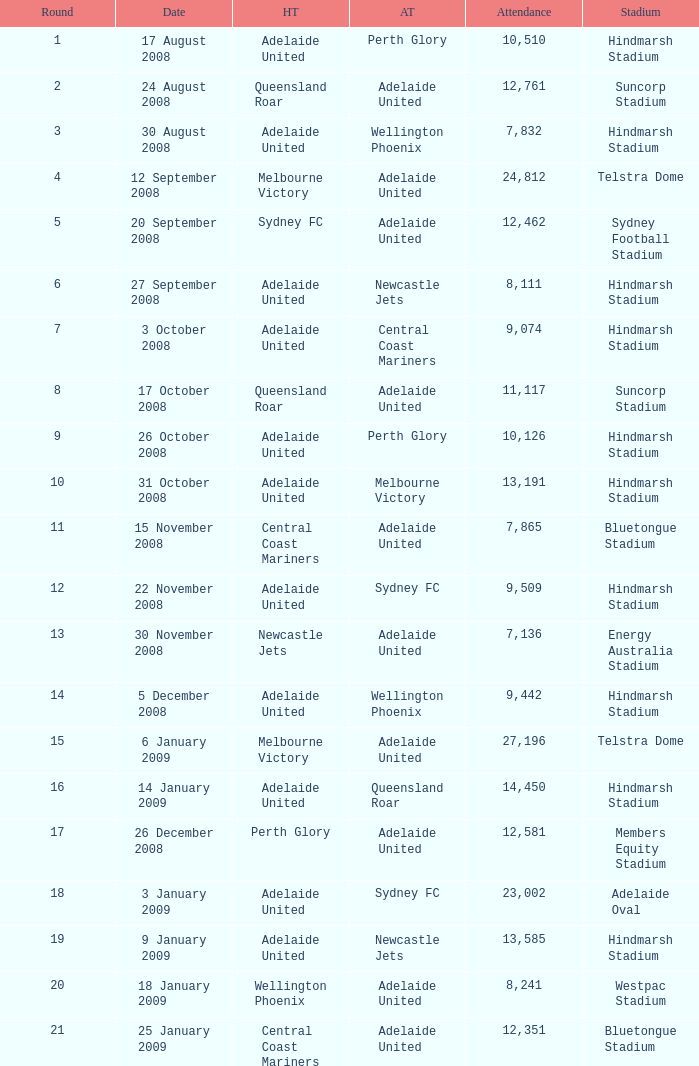What is the round when 11,117 people attended the game on 26 October 2008? 9.0. 